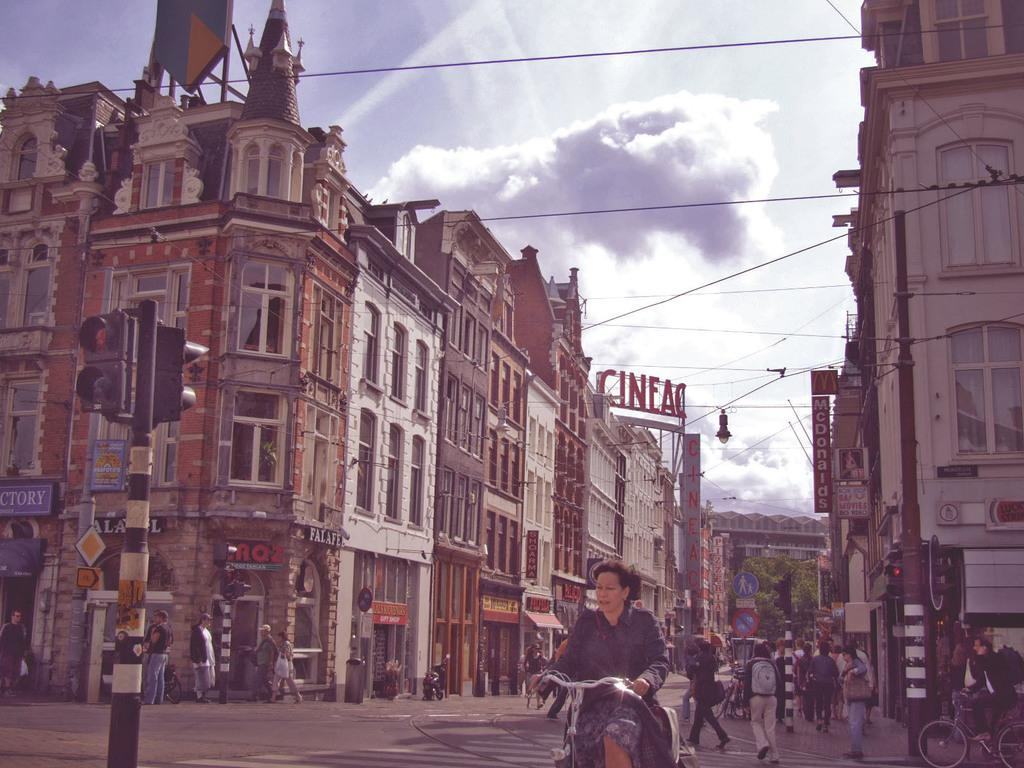What are the people in the image doing? The people in the image are walking on the road. What can be seen in the background of the image? There are buildings in the background of the image. What features do the buildings have? The buildings have windows and doors. What is visible in the sky in the image? The sky is visible in the image. What is located on the left side of the image? There is a signal pole on the left side of the image. What type of furniture can be seen in the image? There is no furniture present in the image. Who is the representative of the people walking in the image? There is no specific representative for the people walking in the image, as they are not part of an organized group or event. 